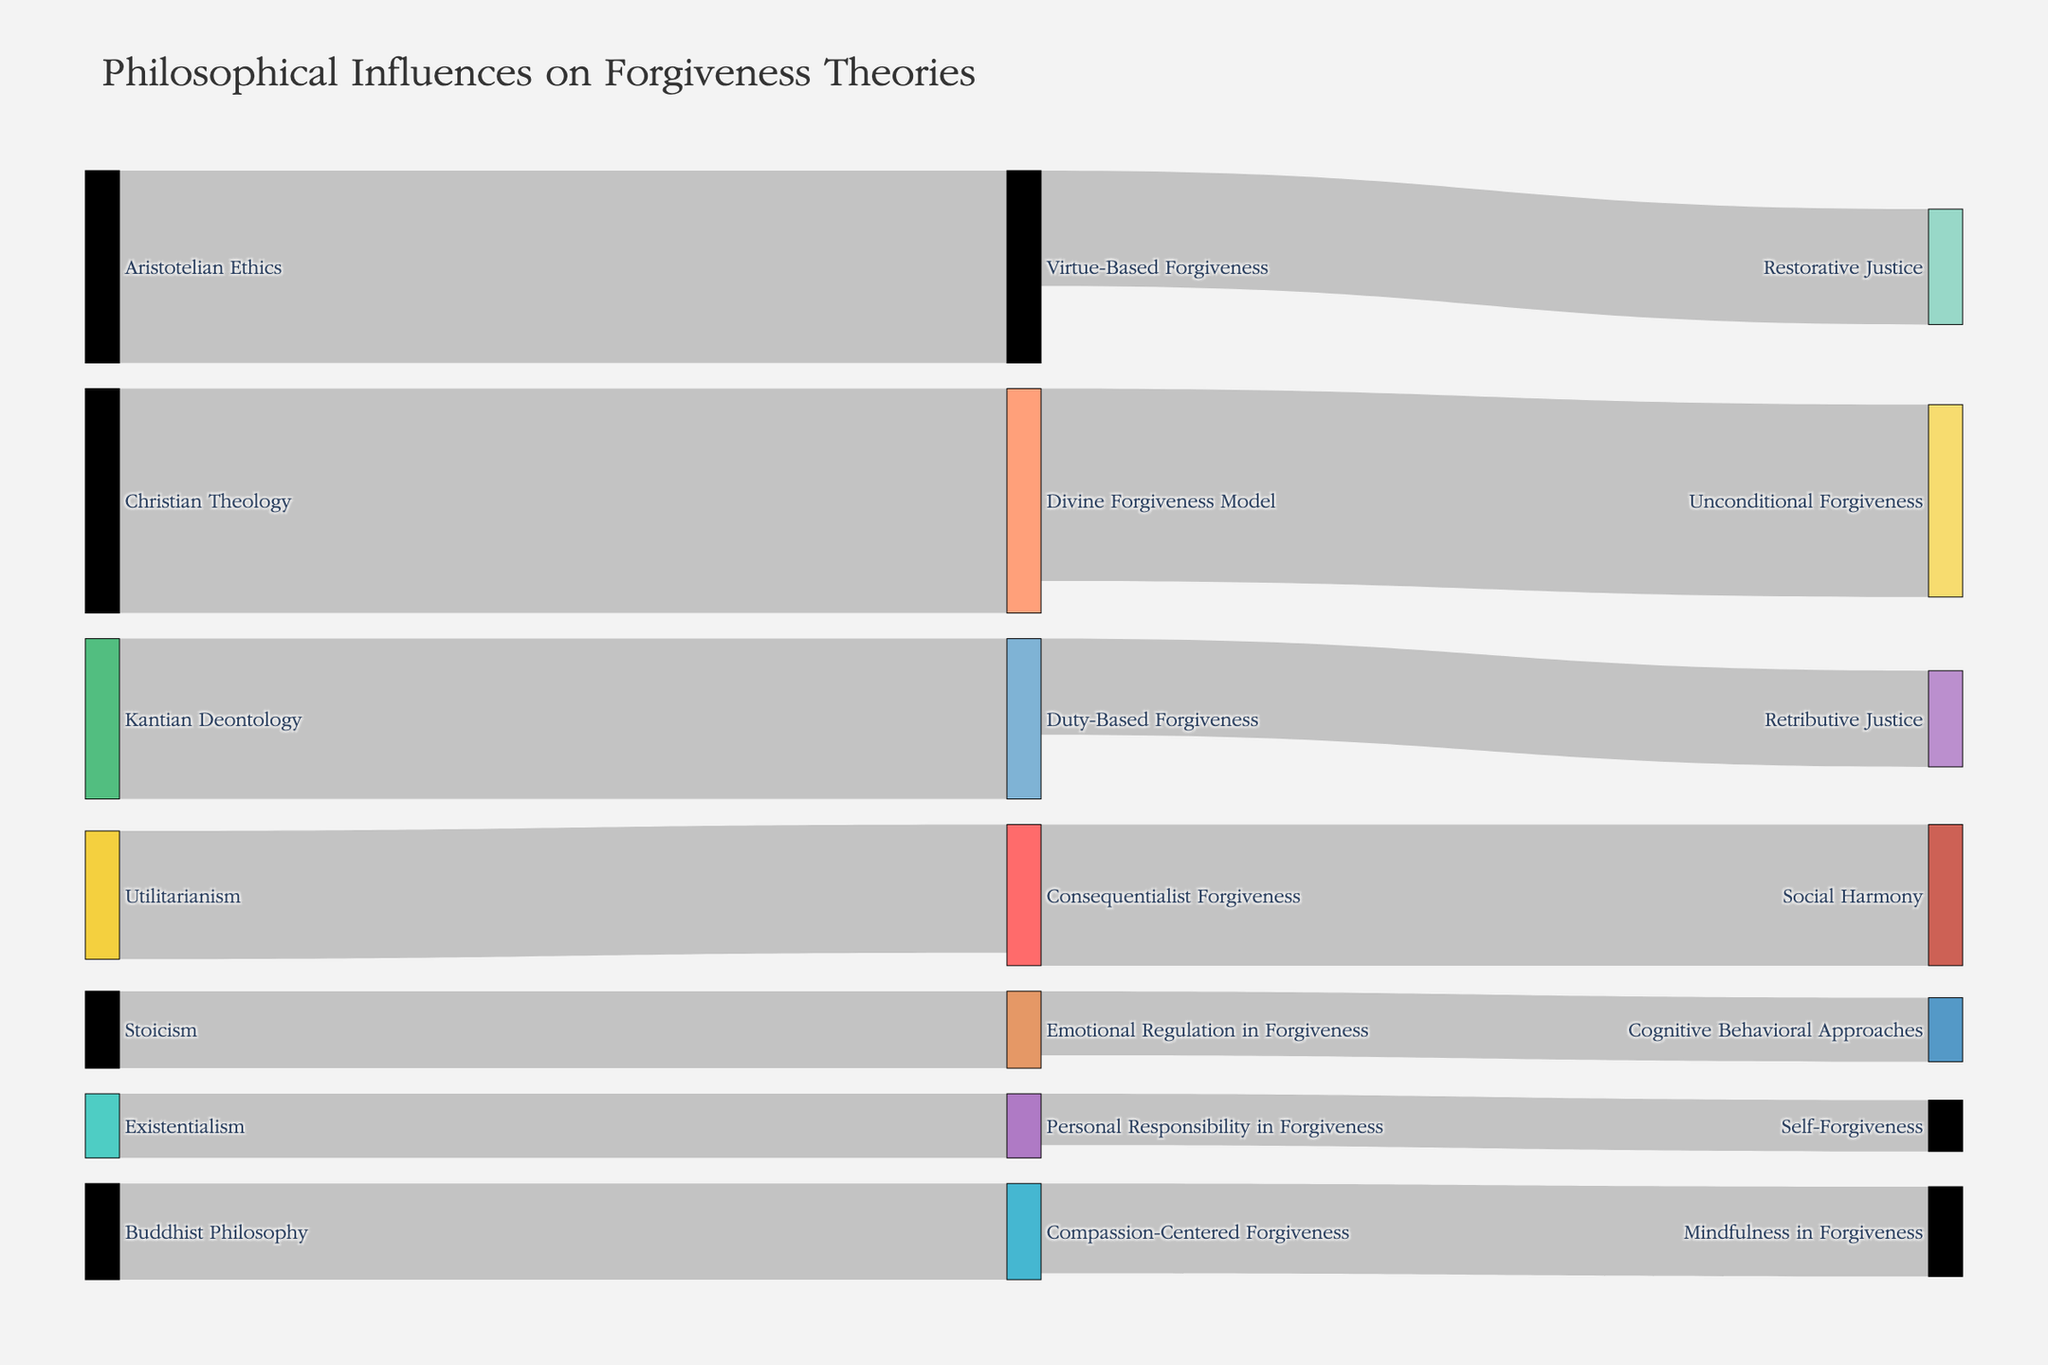What is the title of the figure? The title is found at the top of the figure and typically provides a brief description of what the figure represents.
Answer: Philosophical Influences on Forgiveness Theories Which philosophical tradition has the highest influence on forgiveness theories according to the diagram? Find the node with the highest value among the sources. Christian Theology has a value of 35, which is the highest.
Answer: Christian Theology How many different schools of thought are represented as sources in the figure? Count the number of unique sources (nodes on the left). There are 7: Aristotelian Ethics, Kantian Deontology, Utilitarianism, Christian Theology, Buddhist Philosophy, Existentialism, and Stoicism.
Answer: 7 What is the combined influence of Aristotelian Ethics and Kantian Deontology on forgiveness theories? Add the values of Aristotelian Ethics (30) and Kantian Deontology (25). 30 + 25 = 55.
Answer: 55 Which target node does Virtue-Based Forgiveness connect to, and what is its value? Identify the target linked to Virtue-Based Forgiveness node. It connects to Restorative Justice with a value of 18.
Answer: Restorative Justice, 18 What is the sum of influences directed towards Mindfulness in Forgiveness and Social Harmony? Add the values leading to these targets: Compassion-Centered Forgiveness to Mindfulness in Forgiveness is 14; Consequentialist Forgiveness to Social Harmony is 22. 14 + 22 = 36.
Answer: 36 Compare the influence of Consequentialist Forgiveness and Duty-Based Forgiveness. Which has a higher value? Look at the values linked to each. Consequentialist Forgiveness has a value of 20, whereas Duty-Based Forgiveness has 25. Duty-Based Forgiveness has a higher value.
Answer: Duty-Based Forgiveness Which school of thought is linked to Cognitive Behavioral Approaches, and what is the value of the connection? Find the source node connected to Cognitive Behavioral Approaches. Emotional Regulation in Forgiveness is connected with a value of 10.
Answer: Emotional Regulation in Forgiveness, 10 Explain the flow from Christian Theology to its subsequent target and the target's value. Follow the path from Christian Theology. It links to Divine Forgiveness Model with a value of 35, then from there to Unconditional Forgiveness with a value of 30.
Answer: Divine Forgiveness Model, 35; Unconditional Forgiveness, 30 